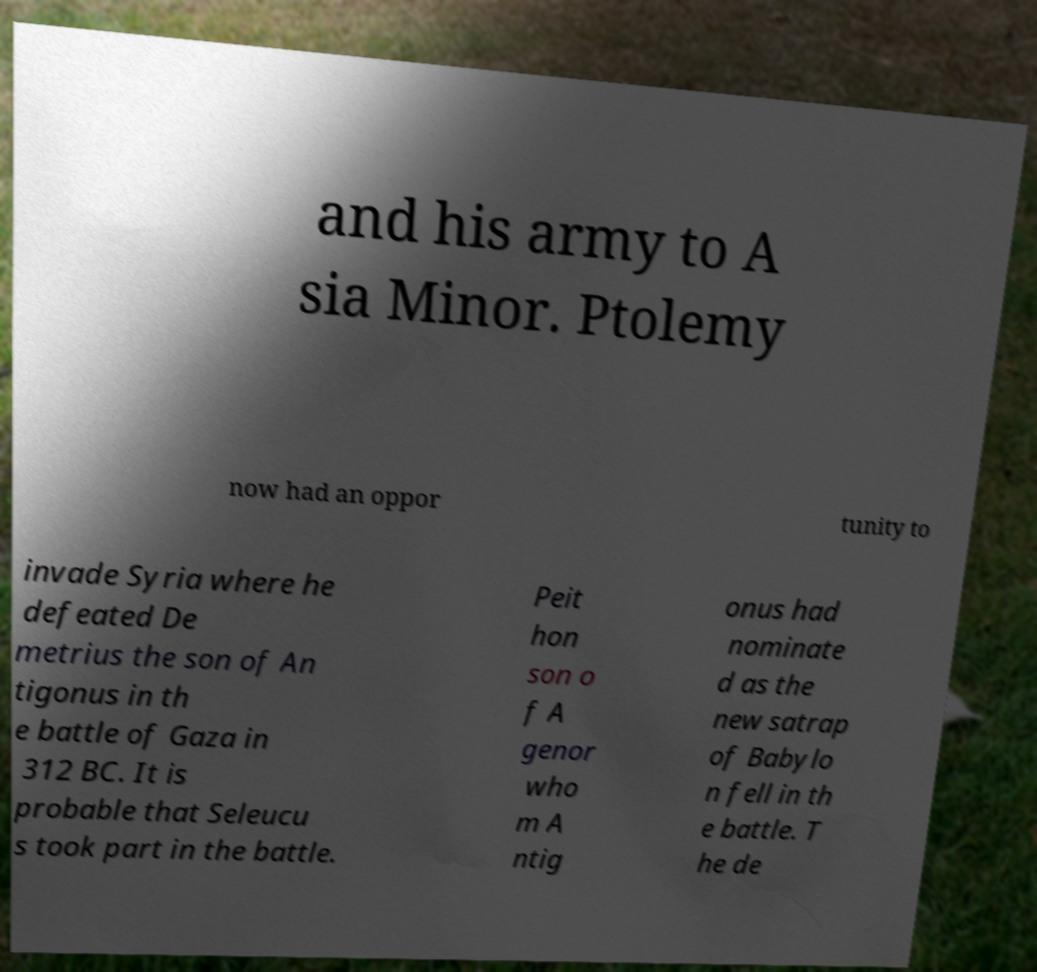Could you assist in decoding the text presented in this image and type it out clearly? and his army to A sia Minor. Ptolemy now had an oppor tunity to invade Syria where he defeated De metrius the son of An tigonus in th e battle of Gaza in 312 BC. It is probable that Seleucu s took part in the battle. Peit hon son o f A genor who m A ntig onus had nominate d as the new satrap of Babylo n fell in th e battle. T he de 